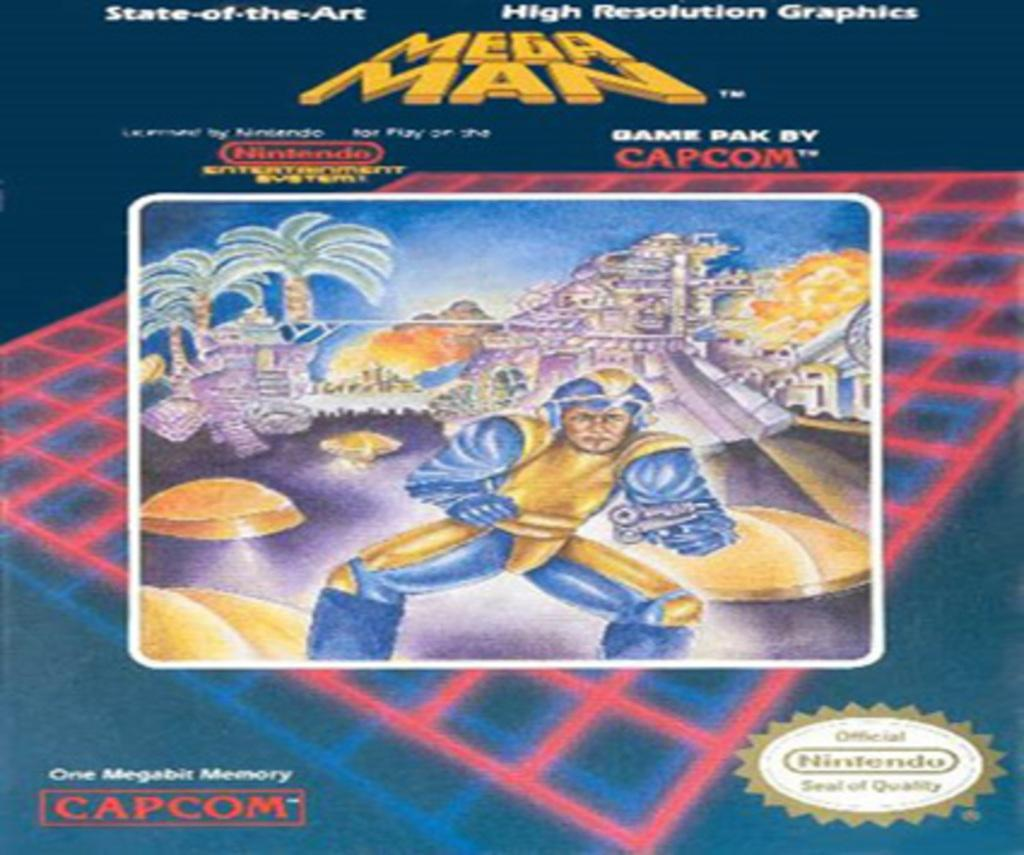What type of image is being described? The image is an animated picture. What can be seen in the background of the image? There are trees in the image. Is there a person present in the image? Yes, there is a person in the image. Are there any words or letters in the image? Yes, there is text written in the image. What type of celery is being used as a paintbrush by the person in the image? There is no celery or paintbrush present in the image; it only features an animated picture with trees, a person, and text. 